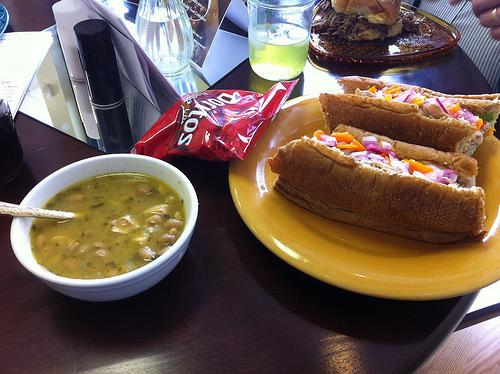Briefly list the main objects on the table. Two sandwiches on a plate, a bowl of green soup, Doritos, salt & pepper shakers, a glass of yellow liquid, and the handle of a spoon sticking out of the soup. What does the person in the image seem to be doing? The person's hand appears while eating a meal, but their main action is not visible. What color is the bag of Doritos and what can you see on the side of it? The bag of Doritos is red, and it has a logo on its side. How many sandwiches are there on the yellow plate and what do they have on top? There are two sandwiches with onions and peppers on top. How many different types of food items can be counted in the image? There are six different types of food items: sandwiches, soup, hotdogs, chips, onion, and orange vegetable. What could be the main theme of this image content? The main theme of the image is a casual meal setting with a variety of different dishes and snacks. Identify the type of soup in the image. The soup is a green soup with chunks of chicken and beans in it. What do the two hotdogs on the yellow plate seem to have on them? The two hotdogs have relish on them. What is inside the clear glass, and how full is it? The clear glass contains yellow liquid (possibly lemonade) and is half full. Describe the dish that contains the soup. The soup is in a white bowl placed on a brown table. What is the style and color of the dish the sandwiches are served on? A round yellow plate Which food item has its logo visible in the image? Doritos chips What can be seen at the extreme left and right of the image? Left: Handle of a spoon sticking out from the soup bowl Which type of juice is in the glass? Yellow fluid, possibly lemonade Explain the arrangement of the items on the table as if they were a diagram. The two sandwiches are placed on a yellow plate, with a white bowl filled with green soup placed nearby. A bag of Doritos lies beside them, and there's a glass of yellow liquid (possibly lemonade) close to the plate with sandwiches. Finally, there are a white salt shaker and a black pepper shaker upon the table. Select the correct color for the following objects:  2. Bag of chips List the following objects: table item to enhance soup flavor, fluid inside the glass, and the soup content. Pepper shaker, yellow fluid (possibly lemonade), chunks of chicken and beans in green soup Is the image showing the entire sandwich or just a part, and which part? Half of a sandwich, and the other half behind it Identify the actions of a person in this image. Eating (only the hand is visible) Describe the soup in the white bowl. Green soup with chunks in it, possibly chicken and beans Identify if there is any person eating and describe the limited part visible. Yes, a hand of a person eating is visible. Identify the text on the side of the bag of chips. Doritos What vegetables are accompanying the two hotdogs in buns? Relish In a modern, artsy language style, describe the eating scene. Amidst an earthy hued stage, flavorful bites of lime-infused soup tango with energizing twirls of lemonade, while crimson chips whisper crunch in harmony with the serenade of two scrumptious sandwiches. From the objects in the image, infer if it's a lunch or dinner time setting. Lunch, since there are sandwiches, soup, chips, and lemonade present Write a styled image caption for this picture. A delightful meal arranges two hearty sandwiches adorned with onions and peppers, a steaming bowl of chunky green soup, and a refreshing glass of lemonade. Describe the appearance of the soup bowl on a brown table. It is a white bowl holding soup, with a spoon sticking out, placed on a brown table. What is on top of the sandwiches? Red onion and orange vegetable 